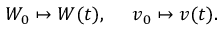Convert formula to latex. <formula><loc_0><loc_0><loc_500><loc_500>W _ { 0 } \mapsto W ( t ) , v _ { 0 } \mapsto v ( t ) .</formula> 